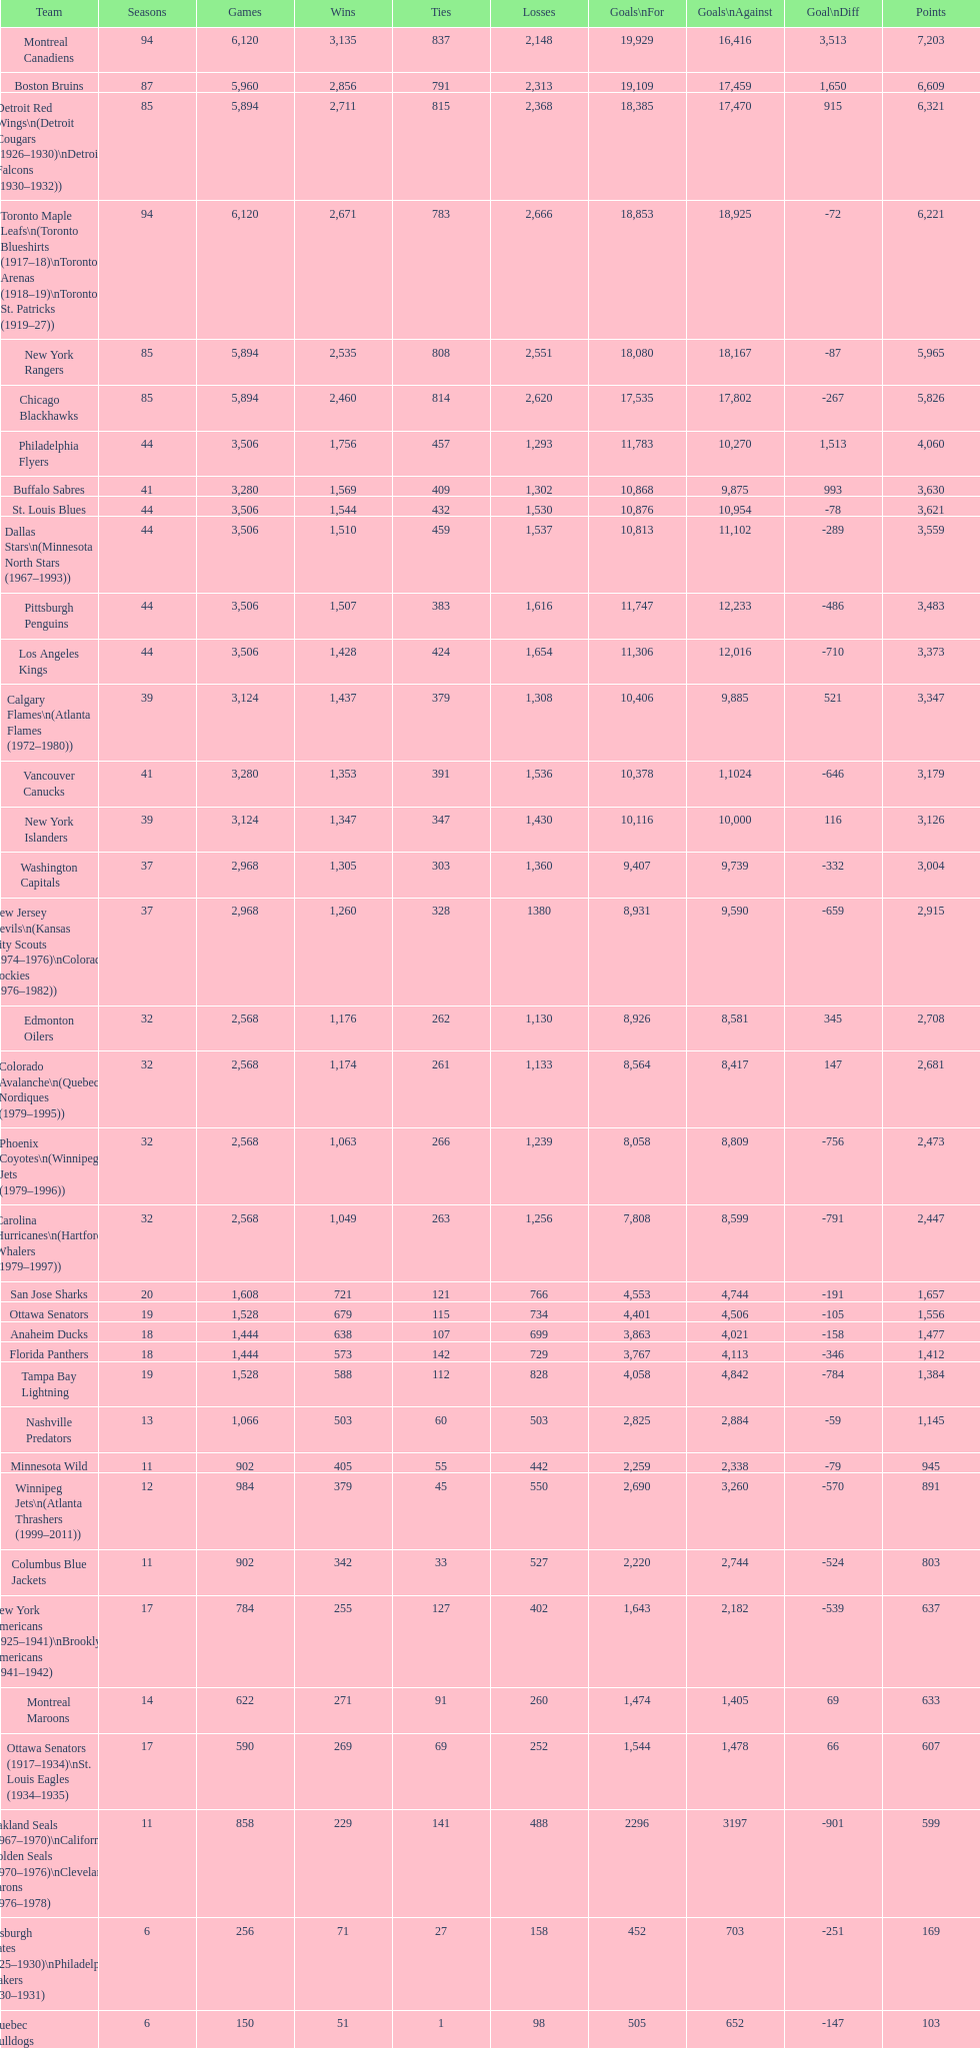How many teams have won more than 1,500 games? 11. 